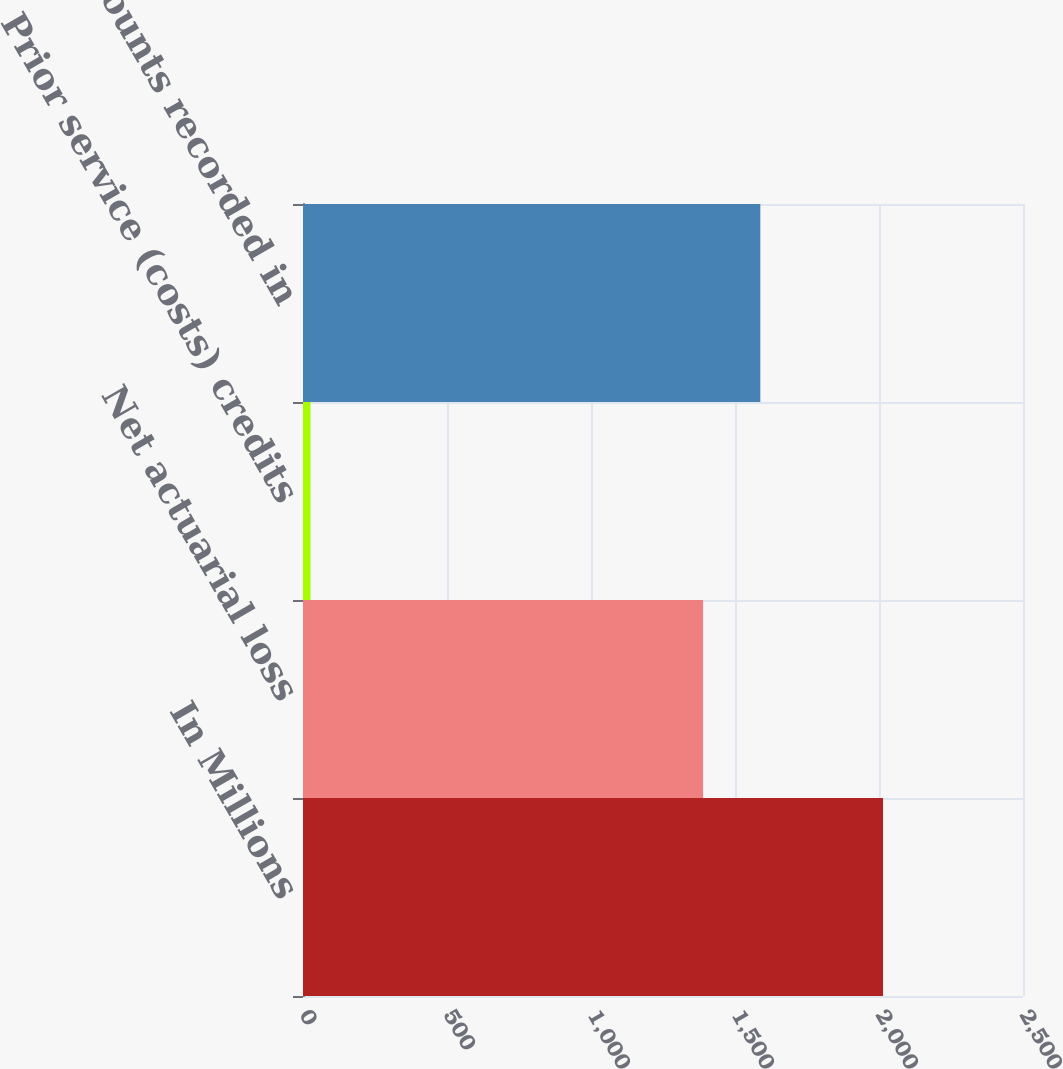Convert chart to OTSL. <chart><loc_0><loc_0><loc_500><loc_500><bar_chart><fcel>In Millions<fcel>Net actuarial loss<fcel>Prior service (costs) credits<fcel>Amounts recorded in<nl><fcel>2014<fcel>1389.2<fcel>26.1<fcel>1587.99<nl></chart> 